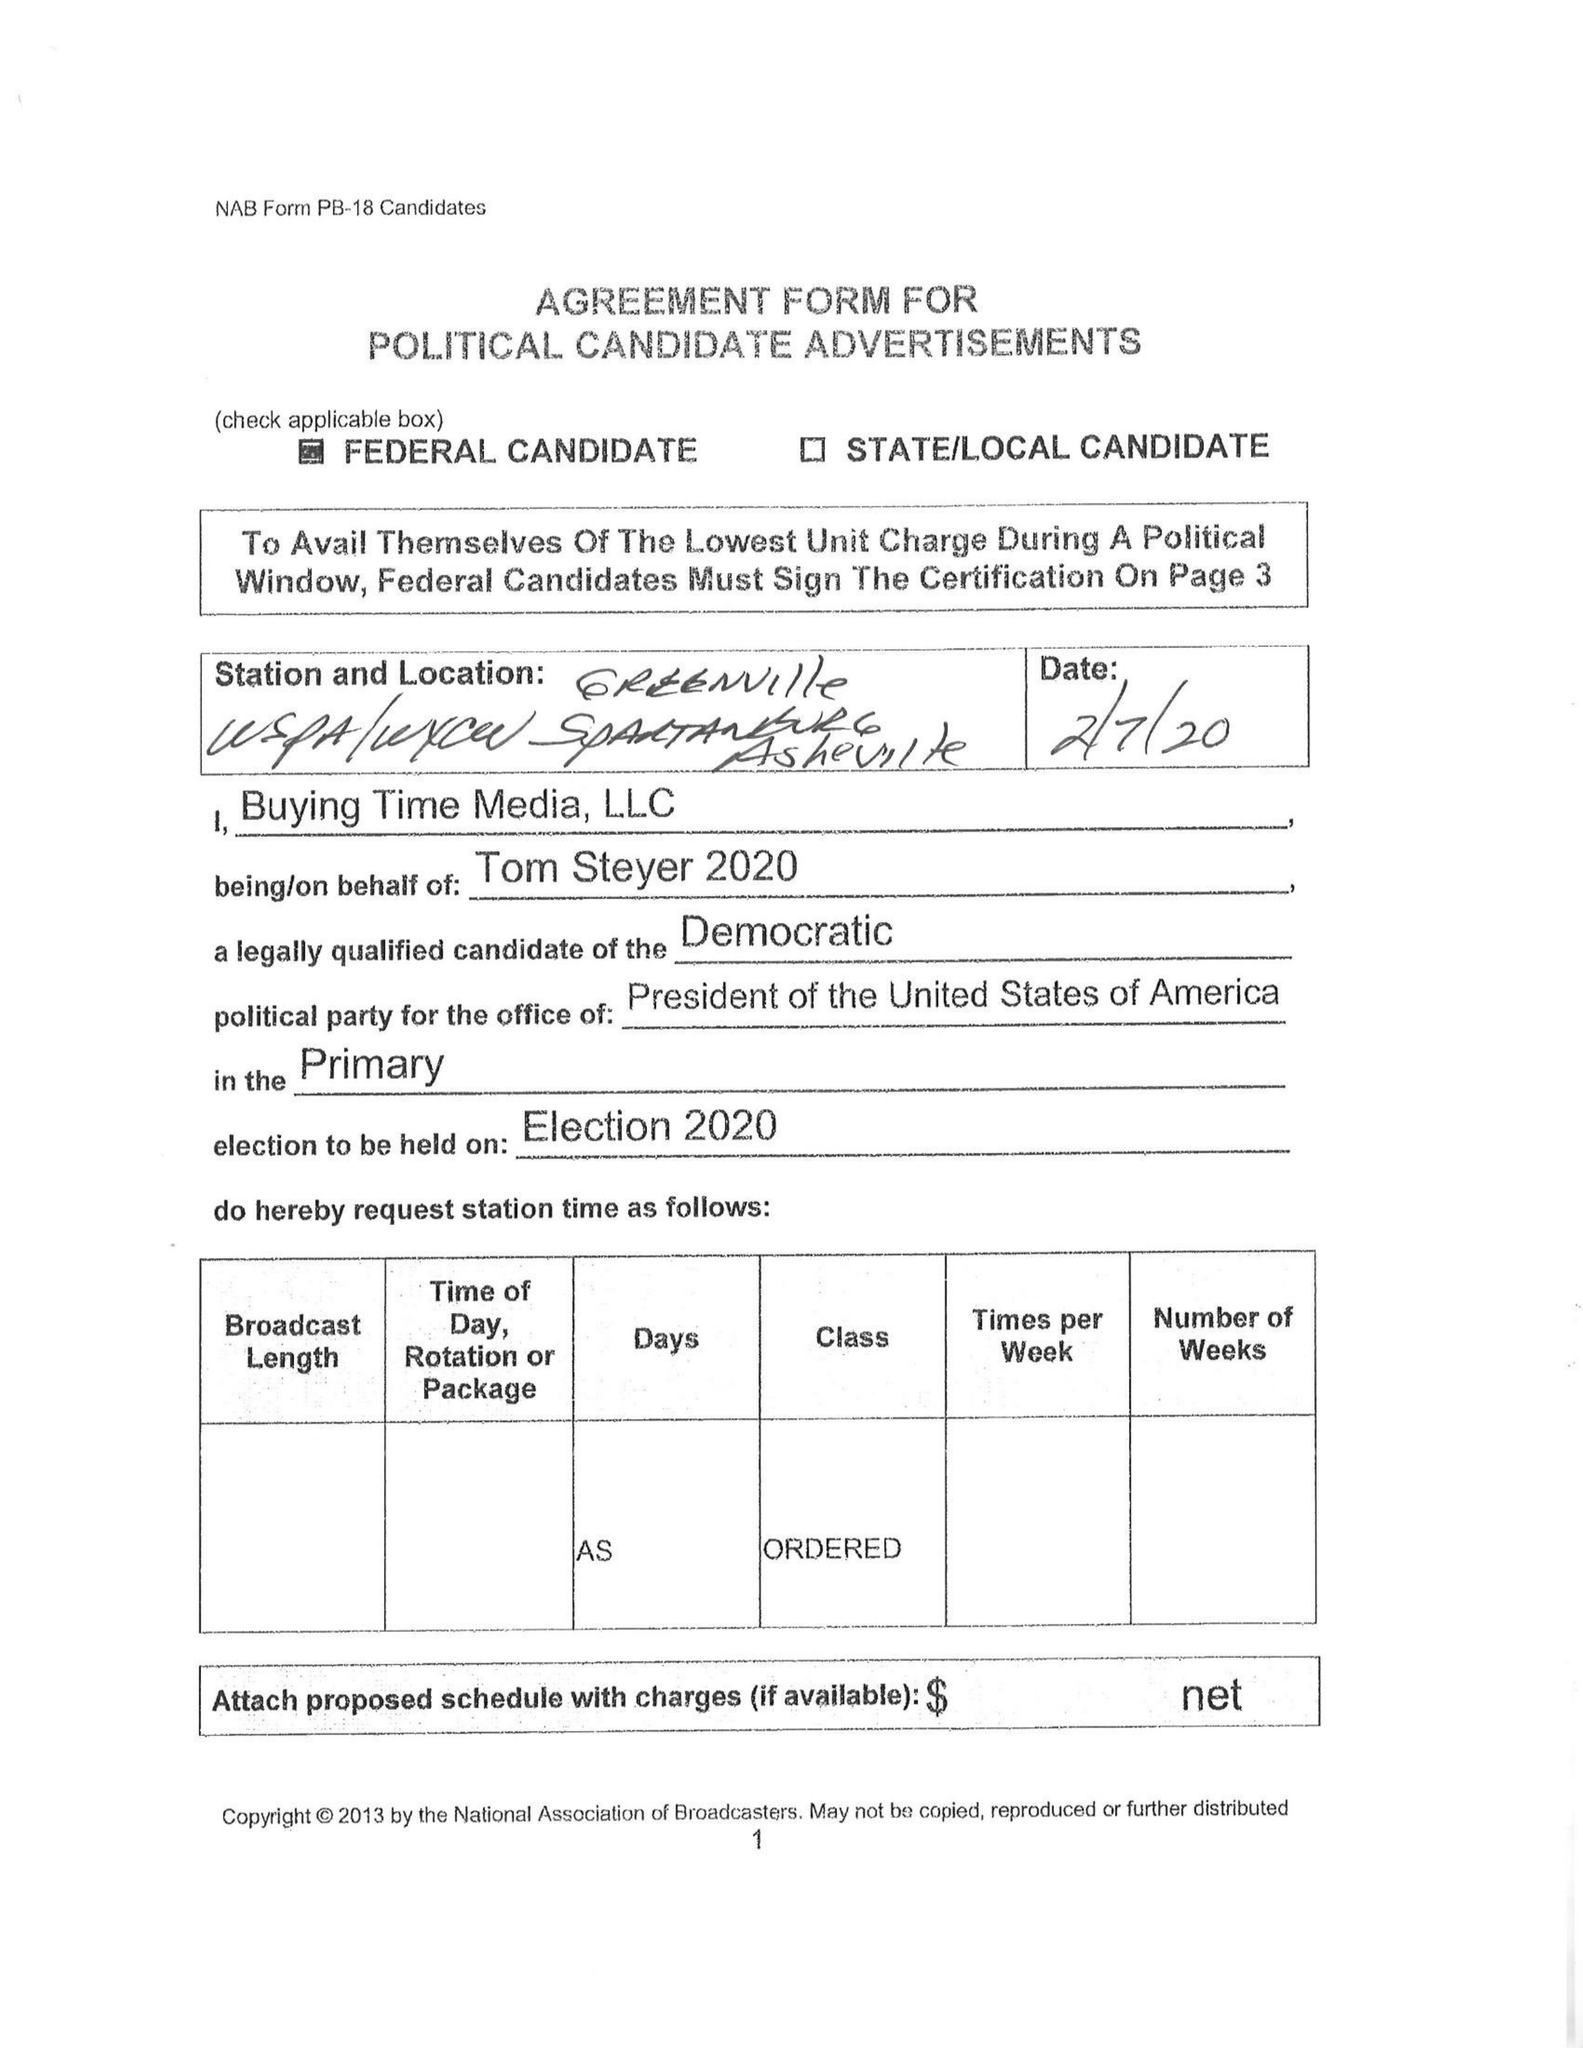What is the value for the flight_to?
Answer the question using a single word or phrase. None 